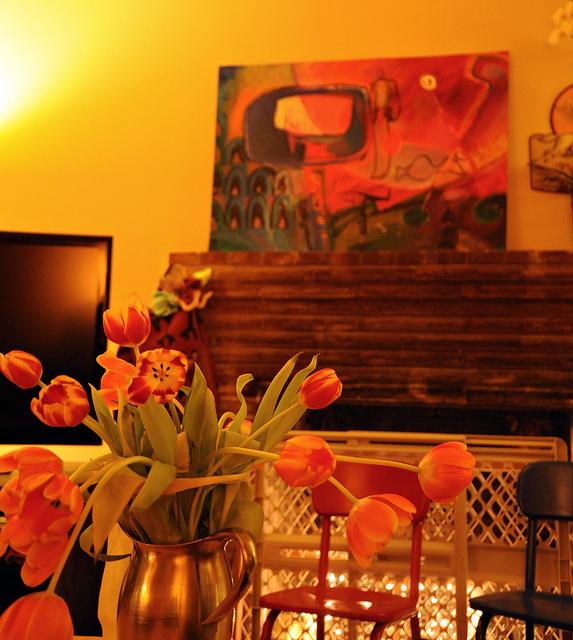Is anyone sitting in the chair?
Keep it brief. No. Is that an abstract painting on the wall?
Give a very brief answer. Yes. What is the mantle made of?
Concise answer only. Wood. 